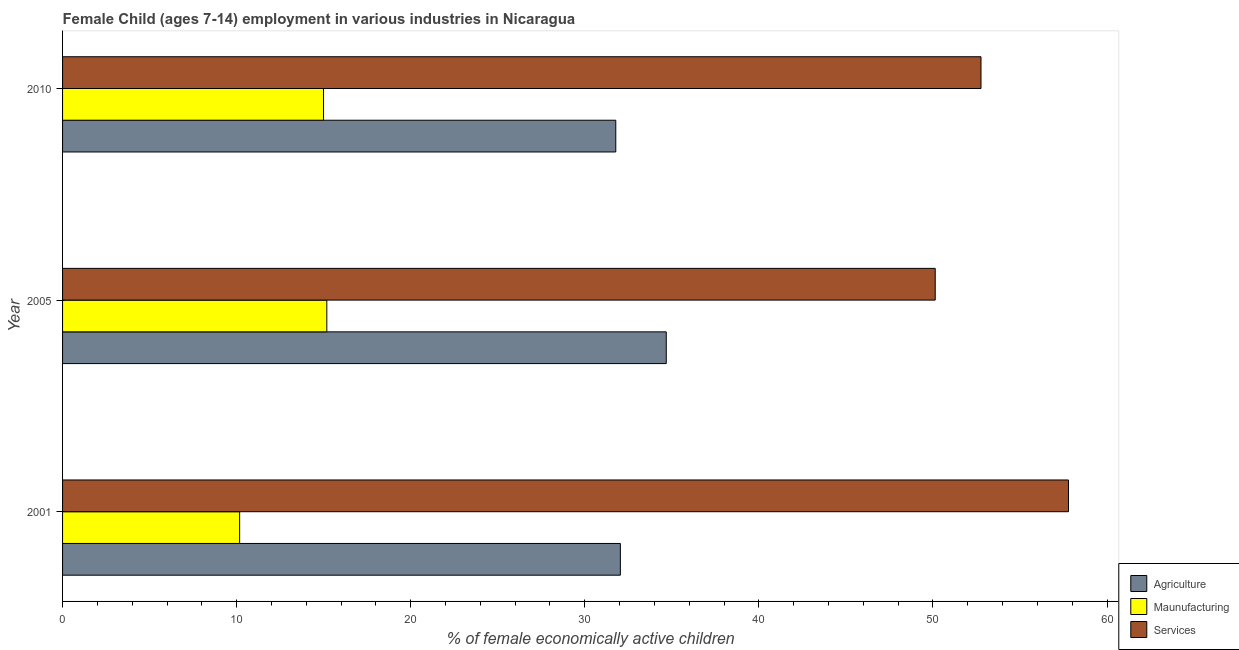How many different coloured bars are there?
Keep it short and to the point. 3. How many bars are there on the 3rd tick from the top?
Provide a succinct answer. 3. How many bars are there on the 2nd tick from the bottom?
Make the answer very short. 3. What is the percentage of economically active children in agriculture in 2001?
Offer a terse response. 32.04. Across all years, what is the maximum percentage of economically active children in services?
Offer a terse response. 57.79. Across all years, what is the minimum percentage of economically active children in manufacturing?
Ensure brevity in your answer.  10.17. In which year was the percentage of economically active children in agriculture minimum?
Offer a terse response. 2010. What is the total percentage of economically active children in manufacturing in the graph?
Give a very brief answer. 40.34. What is the difference between the percentage of economically active children in manufacturing in 2005 and that in 2010?
Make the answer very short. 0.19. What is the difference between the percentage of economically active children in services in 2001 and the percentage of economically active children in agriculture in 2005?
Offer a terse response. 23.11. What is the average percentage of economically active children in manufacturing per year?
Your answer should be very brief. 13.45. In the year 2001, what is the difference between the percentage of economically active children in agriculture and percentage of economically active children in services?
Offer a very short reply. -25.74. In how many years, is the percentage of economically active children in manufacturing greater than 48 %?
Offer a very short reply. 0. Is the percentage of economically active children in manufacturing in 2001 less than that in 2010?
Give a very brief answer. Yes. What is the difference between the highest and the second highest percentage of economically active children in agriculture?
Give a very brief answer. 2.64. What is the difference between the highest and the lowest percentage of economically active children in agriculture?
Keep it short and to the point. 2.9. What does the 3rd bar from the top in 2005 represents?
Ensure brevity in your answer.  Agriculture. What does the 3rd bar from the bottom in 2010 represents?
Offer a terse response. Services. How many bars are there?
Provide a succinct answer. 9. Are all the bars in the graph horizontal?
Your answer should be very brief. Yes. Are the values on the major ticks of X-axis written in scientific E-notation?
Offer a very short reply. No. Does the graph contain any zero values?
Offer a terse response. No. Does the graph contain grids?
Make the answer very short. No. Where does the legend appear in the graph?
Your answer should be very brief. Bottom right. What is the title of the graph?
Provide a short and direct response. Female Child (ages 7-14) employment in various industries in Nicaragua. What is the label or title of the X-axis?
Your answer should be compact. % of female economically active children. What is the label or title of the Y-axis?
Provide a succinct answer. Year. What is the % of female economically active children of Agriculture in 2001?
Your answer should be very brief. 32.04. What is the % of female economically active children of Maunufacturing in 2001?
Provide a short and direct response. 10.17. What is the % of female economically active children of Services in 2001?
Offer a terse response. 57.79. What is the % of female economically active children in Agriculture in 2005?
Your answer should be compact. 34.68. What is the % of female economically active children of Maunufacturing in 2005?
Provide a short and direct response. 15.18. What is the % of female economically active children in Services in 2005?
Your answer should be compact. 50.13. What is the % of female economically active children in Agriculture in 2010?
Your answer should be very brief. 31.78. What is the % of female economically active children of Maunufacturing in 2010?
Your answer should be compact. 14.99. What is the % of female economically active children in Services in 2010?
Your answer should be very brief. 52.76. Across all years, what is the maximum % of female economically active children of Agriculture?
Offer a very short reply. 34.68. Across all years, what is the maximum % of female economically active children in Maunufacturing?
Provide a short and direct response. 15.18. Across all years, what is the maximum % of female economically active children in Services?
Your response must be concise. 57.79. Across all years, what is the minimum % of female economically active children in Agriculture?
Make the answer very short. 31.78. Across all years, what is the minimum % of female economically active children in Maunufacturing?
Offer a terse response. 10.17. Across all years, what is the minimum % of female economically active children of Services?
Give a very brief answer. 50.13. What is the total % of female economically active children of Agriculture in the graph?
Keep it short and to the point. 98.5. What is the total % of female economically active children in Maunufacturing in the graph?
Make the answer very short. 40.34. What is the total % of female economically active children in Services in the graph?
Ensure brevity in your answer.  160.68. What is the difference between the % of female economically active children of Agriculture in 2001 and that in 2005?
Offer a very short reply. -2.64. What is the difference between the % of female economically active children in Maunufacturing in 2001 and that in 2005?
Offer a very short reply. -5.01. What is the difference between the % of female economically active children in Services in 2001 and that in 2005?
Ensure brevity in your answer.  7.66. What is the difference between the % of female economically active children of Agriculture in 2001 and that in 2010?
Keep it short and to the point. 0.26. What is the difference between the % of female economically active children of Maunufacturing in 2001 and that in 2010?
Provide a short and direct response. -4.82. What is the difference between the % of female economically active children of Services in 2001 and that in 2010?
Keep it short and to the point. 5.03. What is the difference between the % of female economically active children in Maunufacturing in 2005 and that in 2010?
Ensure brevity in your answer.  0.19. What is the difference between the % of female economically active children in Services in 2005 and that in 2010?
Keep it short and to the point. -2.63. What is the difference between the % of female economically active children of Agriculture in 2001 and the % of female economically active children of Maunufacturing in 2005?
Ensure brevity in your answer.  16.86. What is the difference between the % of female economically active children of Agriculture in 2001 and the % of female economically active children of Services in 2005?
Keep it short and to the point. -18.09. What is the difference between the % of female economically active children in Maunufacturing in 2001 and the % of female economically active children in Services in 2005?
Provide a short and direct response. -39.96. What is the difference between the % of female economically active children in Agriculture in 2001 and the % of female economically active children in Maunufacturing in 2010?
Offer a terse response. 17.05. What is the difference between the % of female economically active children in Agriculture in 2001 and the % of female economically active children in Services in 2010?
Provide a succinct answer. -20.72. What is the difference between the % of female economically active children of Maunufacturing in 2001 and the % of female economically active children of Services in 2010?
Provide a succinct answer. -42.59. What is the difference between the % of female economically active children in Agriculture in 2005 and the % of female economically active children in Maunufacturing in 2010?
Give a very brief answer. 19.69. What is the difference between the % of female economically active children in Agriculture in 2005 and the % of female economically active children in Services in 2010?
Offer a terse response. -18.08. What is the difference between the % of female economically active children in Maunufacturing in 2005 and the % of female economically active children in Services in 2010?
Your answer should be compact. -37.58. What is the average % of female economically active children in Agriculture per year?
Give a very brief answer. 32.83. What is the average % of female economically active children in Maunufacturing per year?
Offer a very short reply. 13.45. What is the average % of female economically active children in Services per year?
Keep it short and to the point. 53.56. In the year 2001, what is the difference between the % of female economically active children of Agriculture and % of female economically active children of Maunufacturing?
Your answer should be compact. 21.87. In the year 2001, what is the difference between the % of female economically active children in Agriculture and % of female economically active children in Services?
Give a very brief answer. -25.74. In the year 2001, what is the difference between the % of female economically active children in Maunufacturing and % of female economically active children in Services?
Ensure brevity in your answer.  -47.61. In the year 2005, what is the difference between the % of female economically active children of Agriculture and % of female economically active children of Services?
Make the answer very short. -15.45. In the year 2005, what is the difference between the % of female economically active children in Maunufacturing and % of female economically active children in Services?
Your response must be concise. -34.95. In the year 2010, what is the difference between the % of female economically active children in Agriculture and % of female economically active children in Maunufacturing?
Provide a succinct answer. 16.79. In the year 2010, what is the difference between the % of female economically active children of Agriculture and % of female economically active children of Services?
Offer a terse response. -20.98. In the year 2010, what is the difference between the % of female economically active children of Maunufacturing and % of female economically active children of Services?
Your response must be concise. -37.77. What is the ratio of the % of female economically active children of Agriculture in 2001 to that in 2005?
Keep it short and to the point. 0.92. What is the ratio of the % of female economically active children in Maunufacturing in 2001 to that in 2005?
Ensure brevity in your answer.  0.67. What is the ratio of the % of female economically active children in Services in 2001 to that in 2005?
Offer a very short reply. 1.15. What is the ratio of the % of female economically active children of Agriculture in 2001 to that in 2010?
Offer a terse response. 1.01. What is the ratio of the % of female economically active children in Maunufacturing in 2001 to that in 2010?
Give a very brief answer. 0.68. What is the ratio of the % of female economically active children of Services in 2001 to that in 2010?
Your answer should be compact. 1.1. What is the ratio of the % of female economically active children in Agriculture in 2005 to that in 2010?
Offer a terse response. 1.09. What is the ratio of the % of female economically active children of Maunufacturing in 2005 to that in 2010?
Offer a very short reply. 1.01. What is the ratio of the % of female economically active children in Services in 2005 to that in 2010?
Offer a terse response. 0.95. What is the difference between the highest and the second highest % of female economically active children in Agriculture?
Provide a short and direct response. 2.64. What is the difference between the highest and the second highest % of female economically active children of Maunufacturing?
Make the answer very short. 0.19. What is the difference between the highest and the second highest % of female economically active children in Services?
Give a very brief answer. 5.03. What is the difference between the highest and the lowest % of female economically active children of Agriculture?
Provide a succinct answer. 2.9. What is the difference between the highest and the lowest % of female economically active children of Maunufacturing?
Offer a very short reply. 5.01. What is the difference between the highest and the lowest % of female economically active children in Services?
Give a very brief answer. 7.66. 